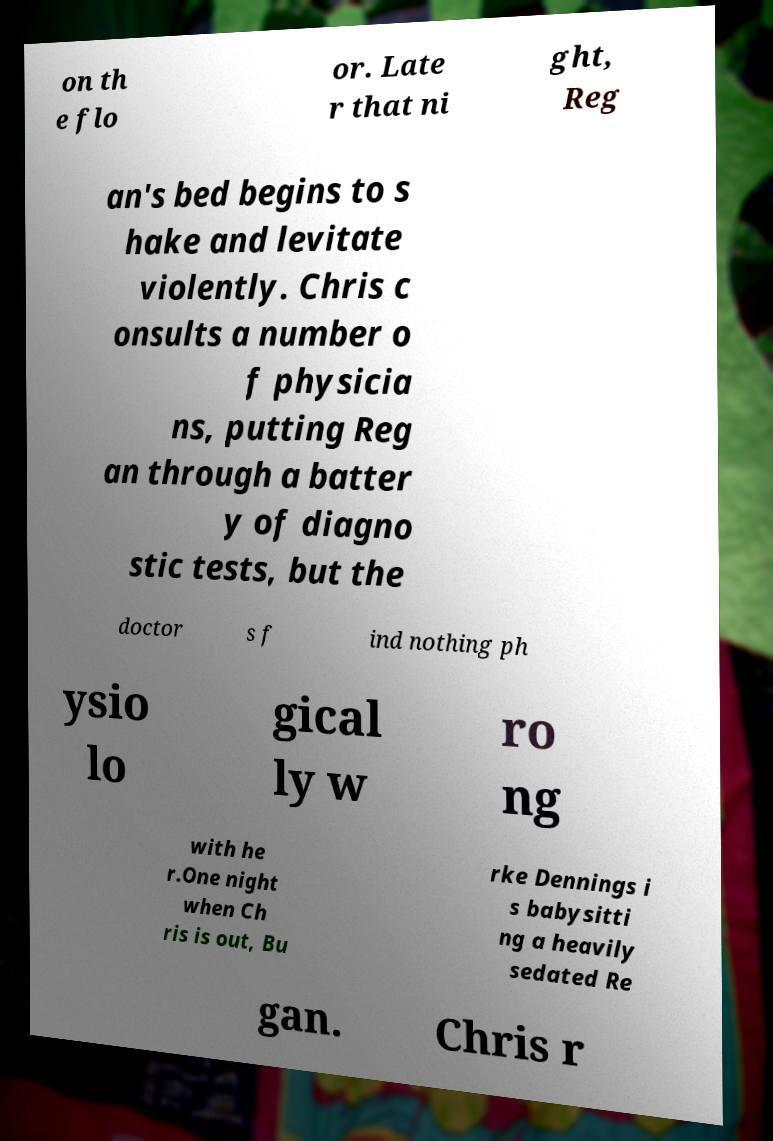Please identify and transcribe the text found in this image. on th e flo or. Late r that ni ght, Reg an's bed begins to s hake and levitate violently. Chris c onsults a number o f physicia ns, putting Reg an through a batter y of diagno stic tests, but the doctor s f ind nothing ph ysio lo gical ly w ro ng with he r.One night when Ch ris is out, Bu rke Dennings i s babysitti ng a heavily sedated Re gan. Chris r 